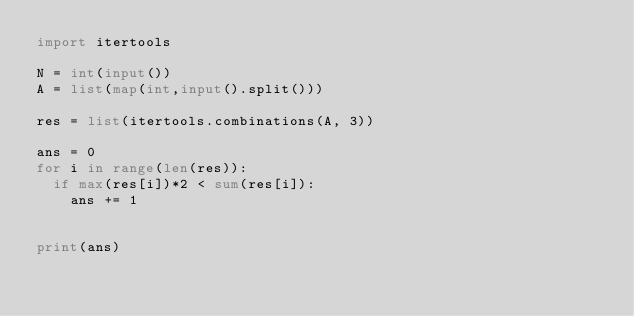Convert code to text. <code><loc_0><loc_0><loc_500><loc_500><_Python_>import itertools

N = int(input())
A = list(map(int,input().split()))

res = list(itertools.combinations(A, 3))

ans = 0
for i in range(len(res)):
  if max(res[i])*2 < sum(res[i]):
    ans += 1
    
    
print(ans)</code> 